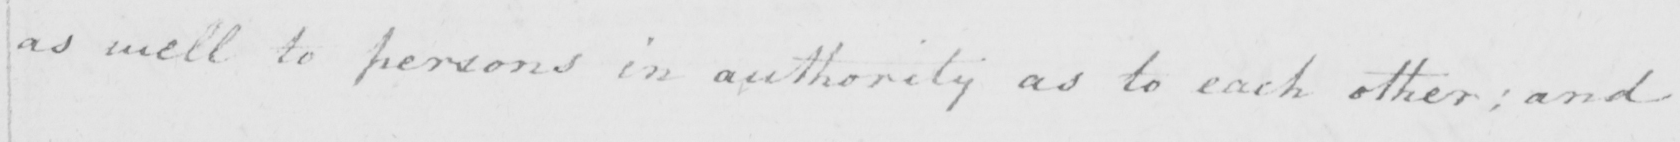What is written in this line of handwriting? as well to persons in authority as to each other ; and 